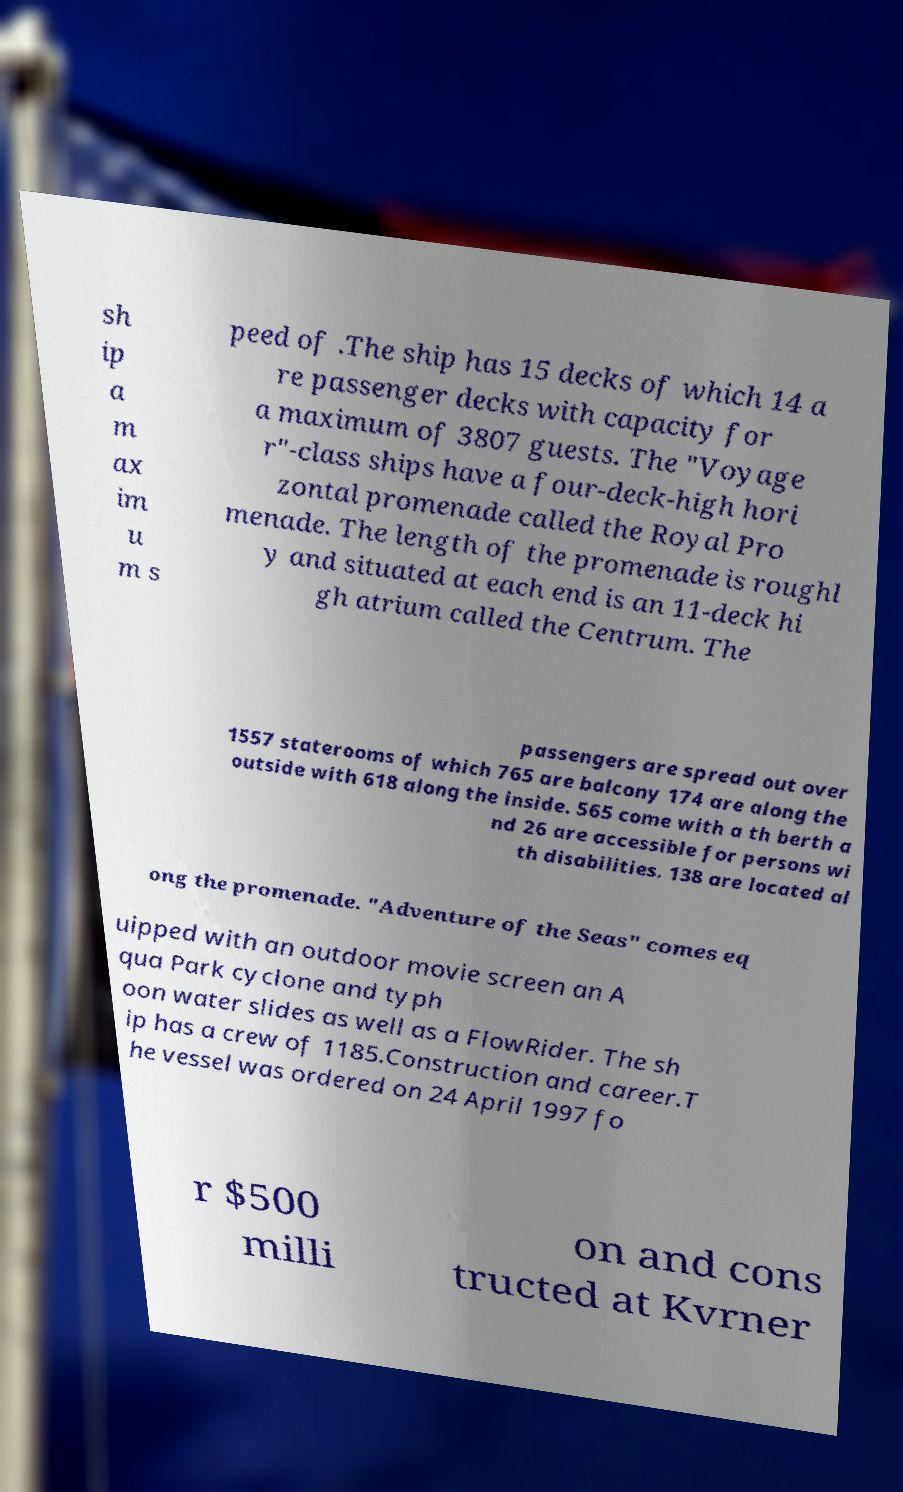Could you extract and type out the text from this image? sh ip a m ax im u m s peed of .The ship has 15 decks of which 14 a re passenger decks with capacity for a maximum of 3807 guests. The "Voyage r"-class ships have a four-deck-high hori zontal promenade called the Royal Pro menade. The length of the promenade is roughl y and situated at each end is an 11-deck hi gh atrium called the Centrum. The passengers are spread out over 1557 staterooms of which 765 are balcony 174 are along the outside with 618 along the inside. 565 come with a th berth a nd 26 are accessible for persons wi th disabilities. 138 are located al ong the promenade. "Adventure of the Seas" comes eq uipped with an outdoor movie screen an A qua Park cyclone and typh oon water slides as well as a FlowRider. The sh ip has a crew of 1185.Construction and career.T he vessel was ordered on 24 April 1997 fo r $500 milli on and cons tructed at Kvrner 